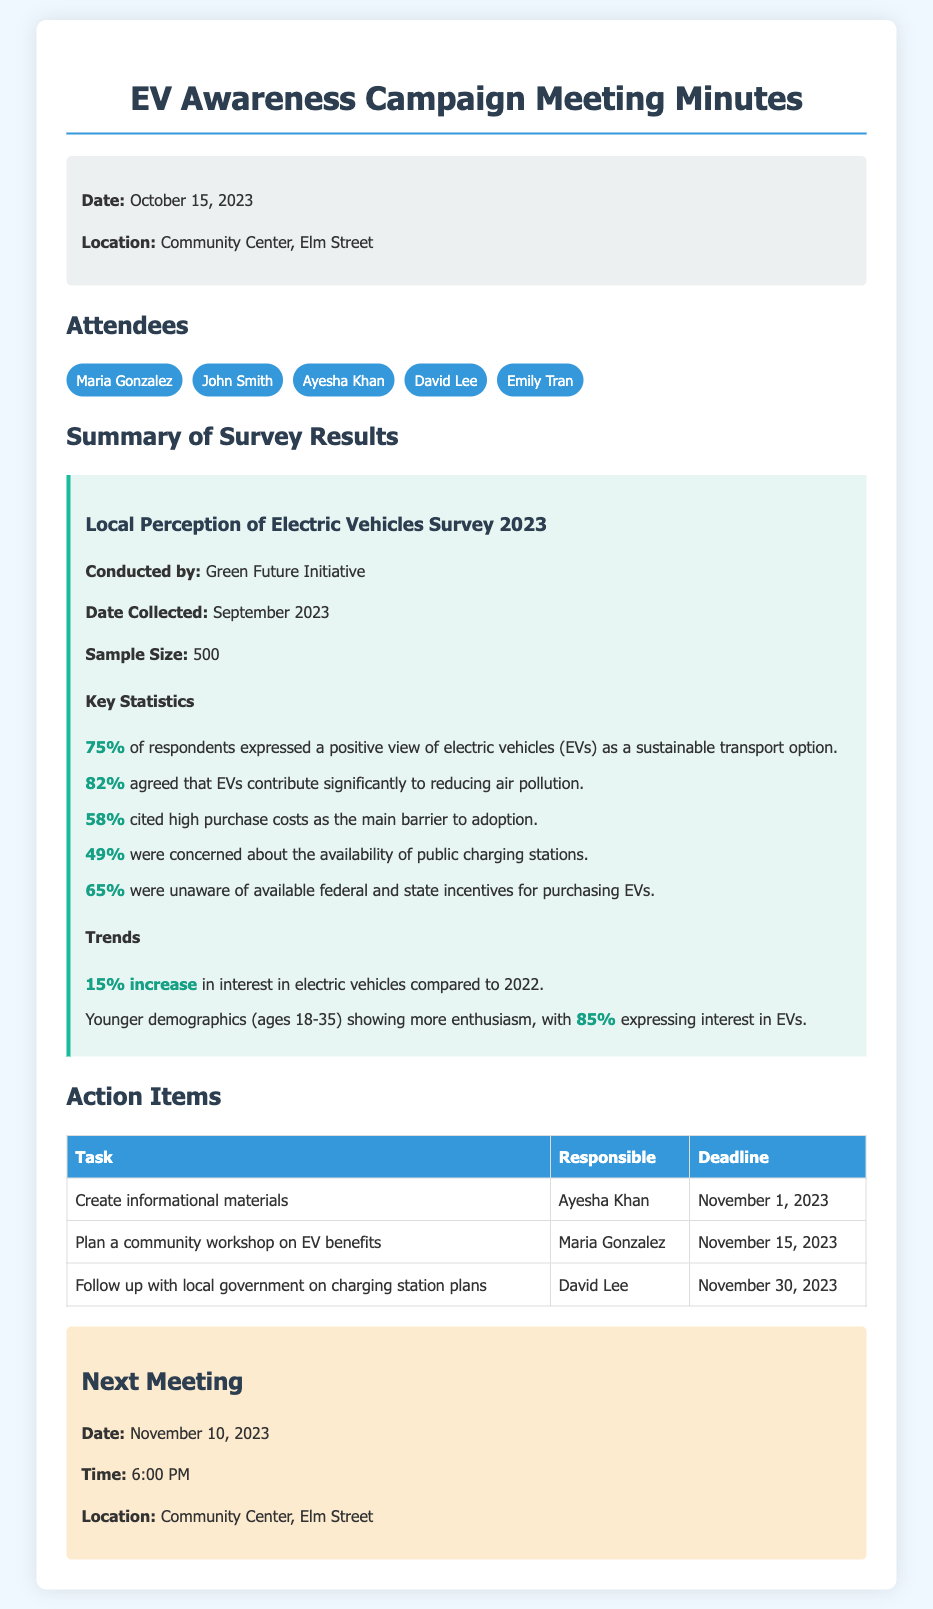What percentage of respondents expressed a positive view of EVs? The document states that 75% of respondents expressed a positive view of electric vehicles.
Answer: 75% What is the sample size of the survey conducted by the Green Future Initiative? The document mentions that the sample size for the survey was 500 respondents.
Answer: 500 What is the main barrier to adoption cited by 58% of respondents? The document indicates that high purchase costs are the main barrier to adoption as cited by 58% of respondents.
Answer: High purchase costs Which demographic shows more enthusiasm for EVs according to the survey? The document notes that younger demographics (ages 18-35) show more enthusiasm for electric vehicles.
Answer: Younger demographics When is the next meeting scheduled? The document provides the date for the next meeting, which is November 10, 2023.
Answer: November 10, 2023 What percentage of respondents were concerned about the availability of public charging stations? The document specifies that 49% of respondents were concerned about the availability of public charging stations.
Answer: 49% Who is responsible for planning a community workshop on EV benefits? According to the document, Maria Gonzalez is responsible for planning the community workshop on EV benefits.
Answer: Maria Gonzalez What percentage of younger respondents express interest in EVs? The document states that 85% of younger respondents (ages 18-35) express interest in electric vehicles.
Answer: 85% How much did interest in electric vehicles increase compared to 2022? The document indicates a 15% increase in interest in electric vehicles compared to the previous year, 2022.
Answer: 15% increase 